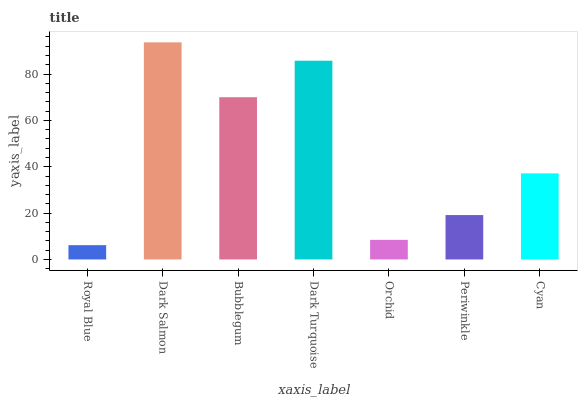Is Bubblegum the minimum?
Answer yes or no. No. Is Bubblegum the maximum?
Answer yes or no. No. Is Dark Salmon greater than Bubblegum?
Answer yes or no. Yes. Is Bubblegum less than Dark Salmon?
Answer yes or no. Yes. Is Bubblegum greater than Dark Salmon?
Answer yes or no. No. Is Dark Salmon less than Bubblegum?
Answer yes or no. No. Is Cyan the high median?
Answer yes or no. Yes. Is Cyan the low median?
Answer yes or no. Yes. Is Dark Turquoise the high median?
Answer yes or no. No. Is Orchid the low median?
Answer yes or no. No. 